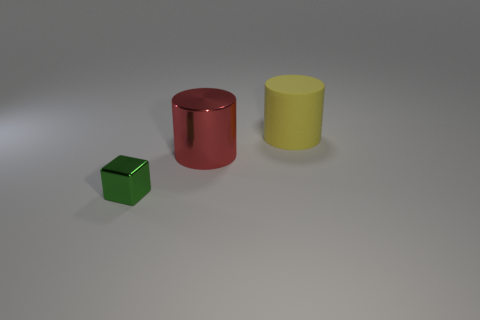Add 3 yellow things. How many objects exist? 6 Subtract all cubes. How many objects are left? 2 Add 3 matte cylinders. How many matte cylinders are left? 4 Add 1 tiny purple rubber blocks. How many tiny purple rubber blocks exist? 1 Subtract 0 brown cylinders. How many objects are left? 3 Subtract all yellow cylinders. Subtract all brown shiny blocks. How many objects are left? 2 